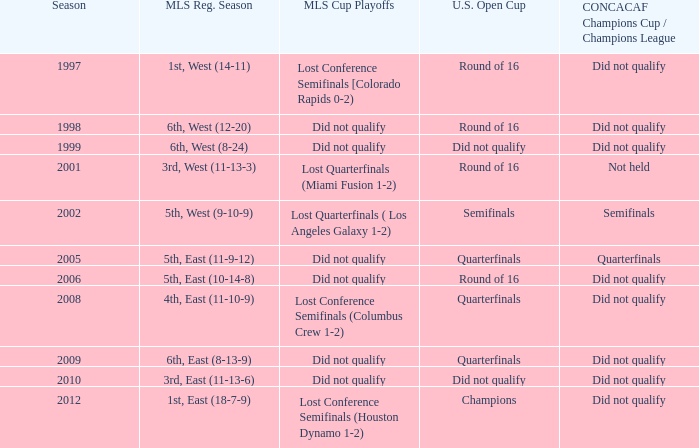How did the team place when they did not qualify for the Concaf Champions Cup but made it to Round of 16 in the U.S. Open Cup? Lost Conference Semifinals [Colorado Rapids 0-2), Did not qualify, Did not qualify. 